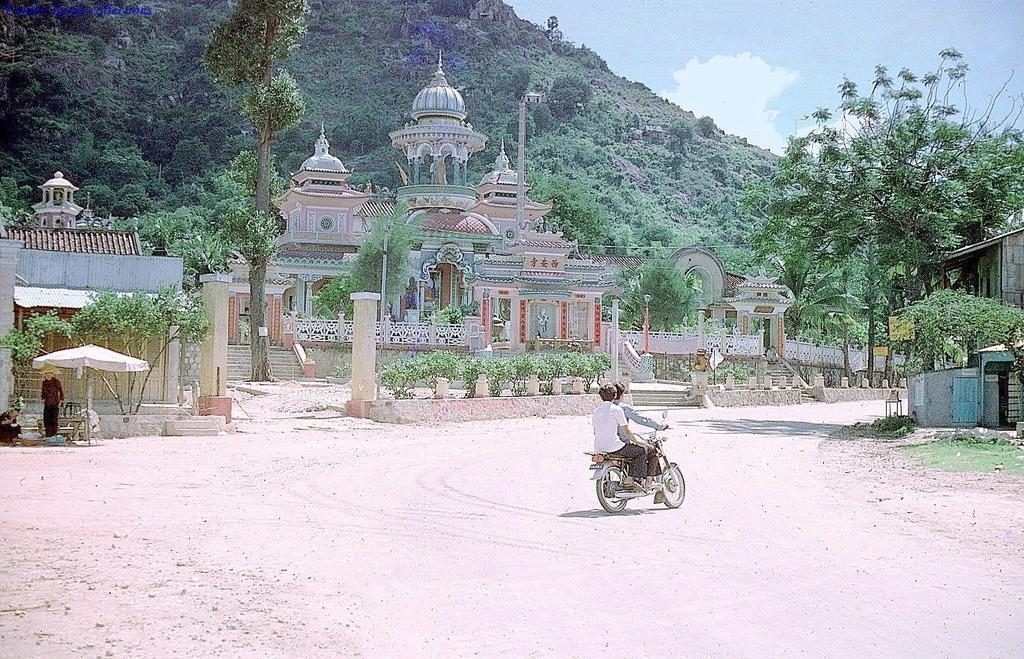Could you give a brief overview of what you see in this image? There are two persons on the bike. Here we can see two persons, umbrella, trees, plants, boards, and ancient architecture. In the background there is a mountain and sky with clouds. 